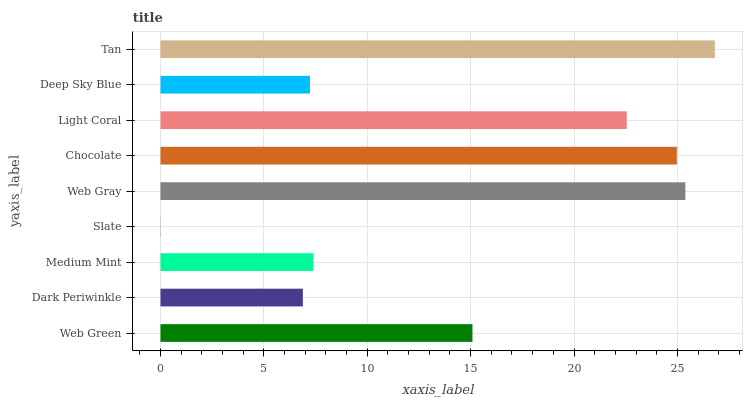Is Slate the minimum?
Answer yes or no. Yes. Is Tan the maximum?
Answer yes or no. Yes. Is Dark Periwinkle the minimum?
Answer yes or no. No. Is Dark Periwinkle the maximum?
Answer yes or no. No. Is Web Green greater than Dark Periwinkle?
Answer yes or no. Yes. Is Dark Periwinkle less than Web Green?
Answer yes or no. Yes. Is Dark Periwinkle greater than Web Green?
Answer yes or no. No. Is Web Green less than Dark Periwinkle?
Answer yes or no. No. Is Web Green the high median?
Answer yes or no. Yes. Is Web Green the low median?
Answer yes or no. Yes. Is Chocolate the high median?
Answer yes or no. No. Is Tan the low median?
Answer yes or no. No. 